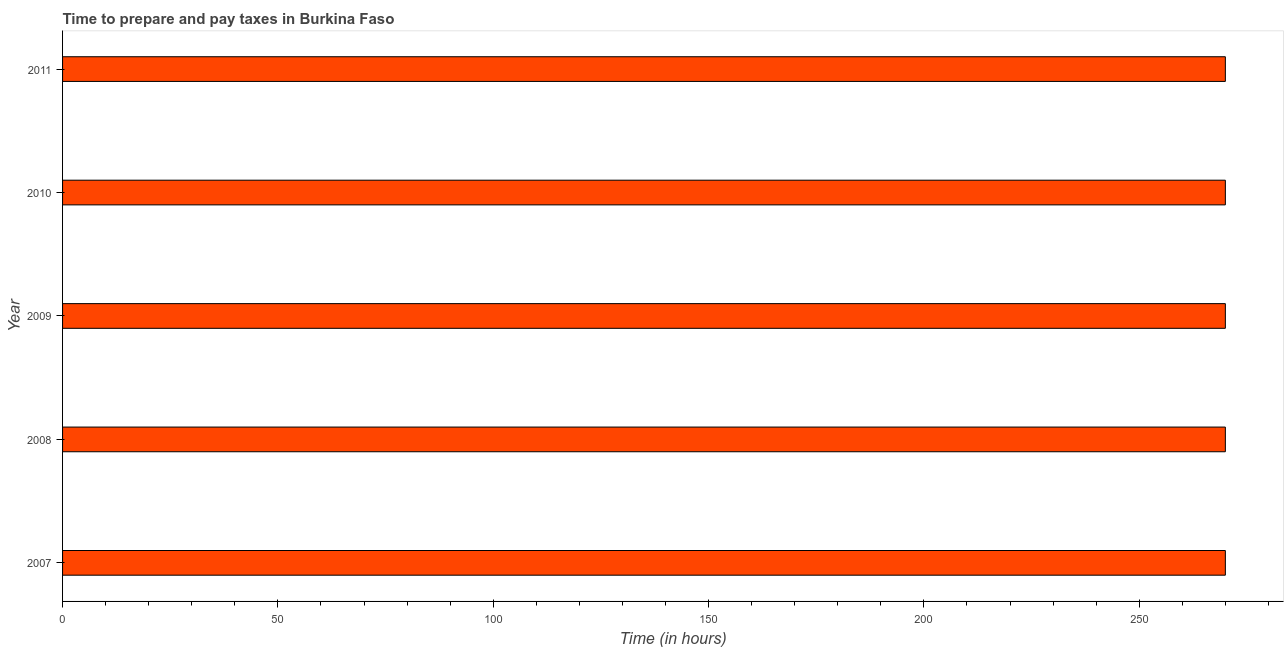Does the graph contain any zero values?
Offer a terse response. No. What is the title of the graph?
Provide a succinct answer. Time to prepare and pay taxes in Burkina Faso. What is the label or title of the X-axis?
Make the answer very short. Time (in hours). What is the label or title of the Y-axis?
Offer a very short reply. Year. What is the time to prepare and pay taxes in 2009?
Offer a very short reply. 270. Across all years, what is the maximum time to prepare and pay taxes?
Make the answer very short. 270. Across all years, what is the minimum time to prepare and pay taxes?
Your answer should be very brief. 270. In which year was the time to prepare and pay taxes maximum?
Your response must be concise. 2007. In which year was the time to prepare and pay taxes minimum?
Provide a short and direct response. 2007. What is the sum of the time to prepare and pay taxes?
Provide a succinct answer. 1350. What is the difference between the time to prepare and pay taxes in 2009 and 2010?
Your response must be concise. 0. What is the average time to prepare and pay taxes per year?
Your answer should be compact. 270. What is the median time to prepare and pay taxes?
Ensure brevity in your answer.  270. In how many years, is the time to prepare and pay taxes greater than 90 hours?
Your answer should be compact. 5. What is the ratio of the time to prepare and pay taxes in 2009 to that in 2011?
Offer a terse response. 1. Is the time to prepare and pay taxes in 2007 less than that in 2010?
Provide a short and direct response. No. What is the difference between the highest and the second highest time to prepare and pay taxes?
Keep it short and to the point. 0. Is the sum of the time to prepare and pay taxes in 2010 and 2011 greater than the maximum time to prepare and pay taxes across all years?
Keep it short and to the point. Yes. How many bars are there?
Offer a very short reply. 5. Are all the bars in the graph horizontal?
Make the answer very short. Yes. How many years are there in the graph?
Your response must be concise. 5. What is the difference between two consecutive major ticks on the X-axis?
Keep it short and to the point. 50. What is the Time (in hours) of 2007?
Ensure brevity in your answer.  270. What is the Time (in hours) of 2008?
Your answer should be very brief. 270. What is the Time (in hours) in 2009?
Offer a terse response. 270. What is the Time (in hours) in 2010?
Give a very brief answer. 270. What is the Time (in hours) in 2011?
Offer a terse response. 270. What is the difference between the Time (in hours) in 2008 and 2009?
Ensure brevity in your answer.  0. What is the difference between the Time (in hours) in 2008 and 2010?
Ensure brevity in your answer.  0. What is the difference between the Time (in hours) in 2008 and 2011?
Provide a succinct answer. 0. What is the ratio of the Time (in hours) in 2007 to that in 2010?
Offer a terse response. 1. What is the ratio of the Time (in hours) in 2008 to that in 2010?
Make the answer very short. 1. What is the ratio of the Time (in hours) in 2009 to that in 2010?
Your answer should be compact. 1. What is the ratio of the Time (in hours) in 2010 to that in 2011?
Ensure brevity in your answer.  1. 